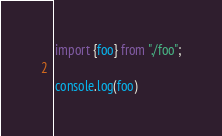Convert code to text. <code><loc_0><loc_0><loc_500><loc_500><_JavaScript_>import {foo} from "./foo";

console.log(foo)
</code> 